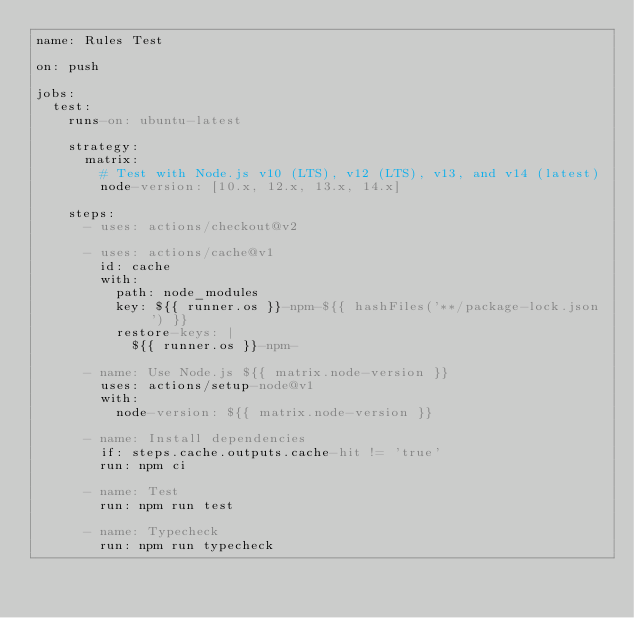Convert code to text. <code><loc_0><loc_0><loc_500><loc_500><_YAML_>name: Rules Test

on: push

jobs:
  test:
    runs-on: ubuntu-latest

    strategy:
      matrix:
        # Test with Node.js v10 (LTS), v12 (LTS), v13, and v14 (latest)
        node-version: [10.x, 12.x, 13.x, 14.x]

    steps:
      - uses: actions/checkout@v2

      - uses: actions/cache@v1
        id: cache
        with:
          path: node_modules
          key: ${{ runner.os }}-npm-${{ hashFiles('**/package-lock.json') }}
          restore-keys: |
            ${{ runner.os }}-npm-

      - name: Use Node.js ${{ matrix.node-version }}
        uses: actions/setup-node@v1
        with:
          node-version: ${{ matrix.node-version }}

      - name: Install dependencies
        if: steps.cache.outputs.cache-hit != 'true'
        run: npm ci

      - name: Test
        run: npm run test

      - name: Typecheck
        run: npm run typecheck
</code> 